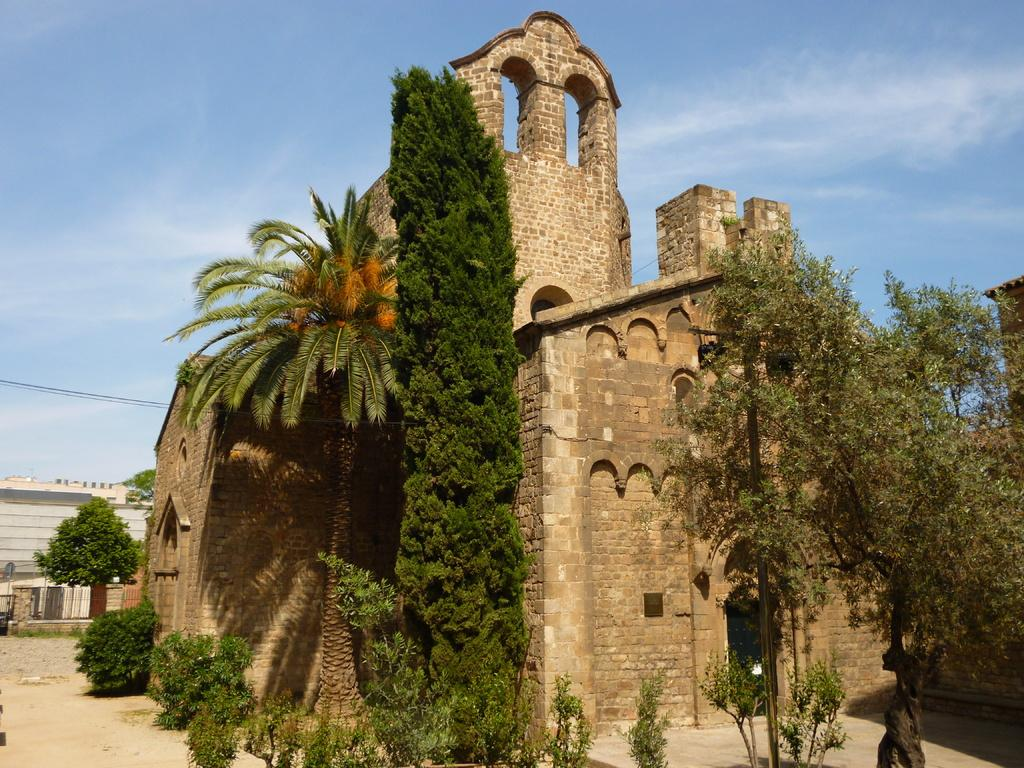What type of vegetation can be seen in the image? There are trees and plants visible in the image. What architectural feature can be seen in the background of the image? There is a wall visible in the background of the image. What else can be seen in the background of the image? There are wires and the sky visible in the background of the image. What type of town is visible in the image? There is no town present in the image. What substance is being used by the bear in the image? There is no bear present in the image. 